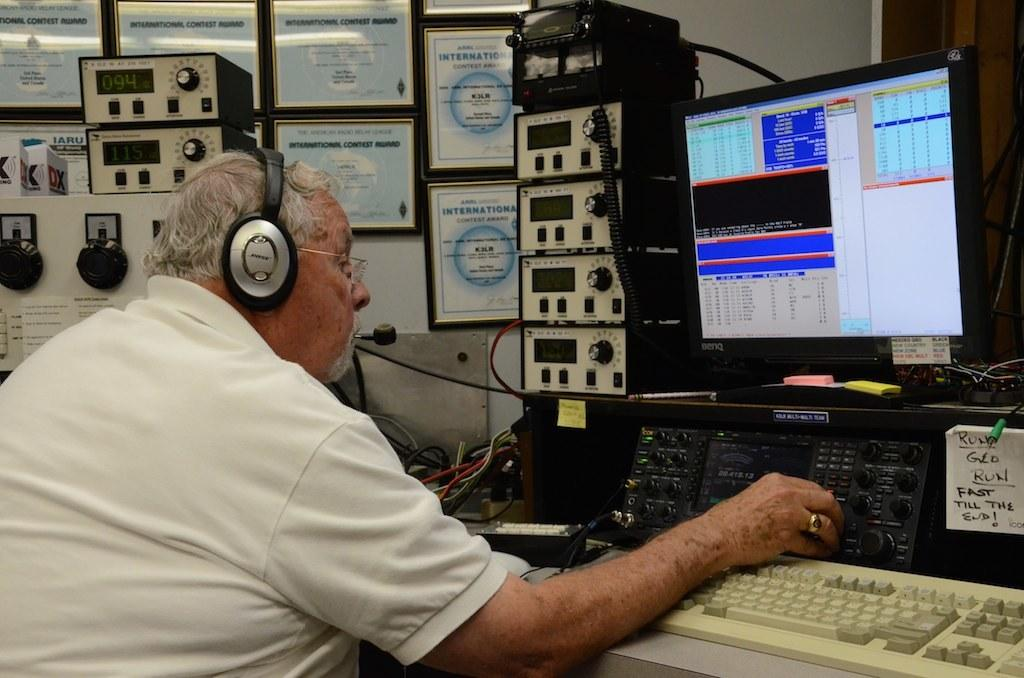<image>
Describe the image concisely. A man wearing Bose earphones sits in front of a bank of electronics. 